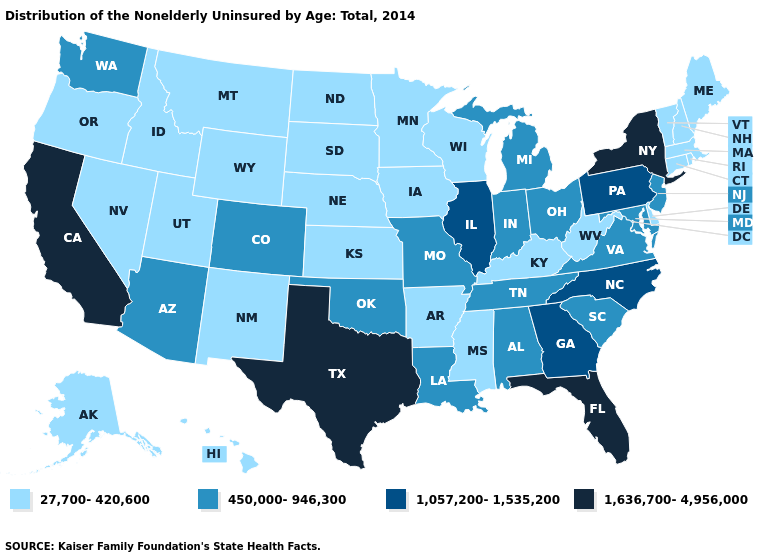What is the value of Washington?
Be succinct. 450,000-946,300. Does New York have the lowest value in the USA?
Write a very short answer. No. Among the states that border Maryland , which have the lowest value?
Be succinct. Delaware, West Virginia. What is the lowest value in the Northeast?
Be succinct. 27,700-420,600. Does Texas have a higher value than New York?
Write a very short answer. No. Name the states that have a value in the range 450,000-946,300?
Short answer required. Alabama, Arizona, Colorado, Indiana, Louisiana, Maryland, Michigan, Missouri, New Jersey, Ohio, Oklahoma, South Carolina, Tennessee, Virginia, Washington. What is the lowest value in states that border Arizona?
Give a very brief answer. 27,700-420,600. Name the states that have a value in the range 450,000-946,300?
Write a very short answer. Alabama, Arizona, Colorado, Indiana, Louisiana, Maryland, Michigan, Missouri, New Jersey, Ohio, Oklahoma, South Carolina, Tennessee, Virginia, Washington. Which states have the lowest value in the USA?
Concise answer only. Alaska, Arkansas, Connecticut, Delaware, Hawaii, Idaho, Iowa, Kansas, Kentucky, Maine, Massachusetts, Minnesota, Mississippi, Montana, Nebraska, Nevada, New Hampshire, New Mexico, North Dakota, Oregon, Rhode Island, South Dakota, Utah, Vermont, West Virginia, Wisconsin, Wyoming. What is the value of California?
Write a very short answer. 1,636,700-4,956,000. Name the states that have a value in the range 1,636,700-4,956,000?
Be succinct. California, Florida, New York, Texas. Name the states that have a value in the range 1,057,200-1,535,200?
Write a very short answer. Georgia, Illinois, North Carolina, Pennsylvania. Does New York have a higher value than Florida?
Concise answer only. No. Does Maine have the lowest value in the USA?
Write a very short answer. Yes. Which states hav the highest value in the Northeast?
Be succinct. New York. 